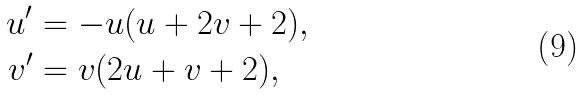Convert formula to latex. <formula><loc_0><loc_0><loc_500><loc_500>u ^ { \prime } & = - u ( u + 2 v + 2 ) , \\ v ^ { \prime } & = v ( 2 u + v + 2 ) ,</formula> 